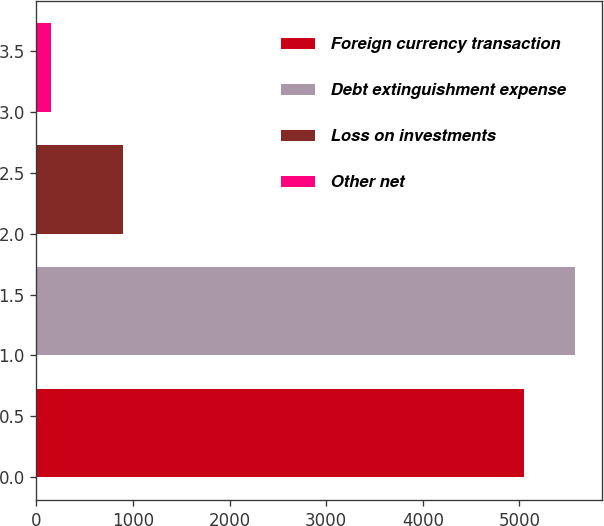Convert chart to OTSL. <chart><loc_0><loc_0><loc_500><loc_500><bar_chart><fcel>Foreign currency transaction<fcel>Debt extinguishment expense<fcel>Loss on investments<fcel>Other net<nl><fcel>5045<fcel>5573.3<fcel>901<fcel>148<nl></chart> 